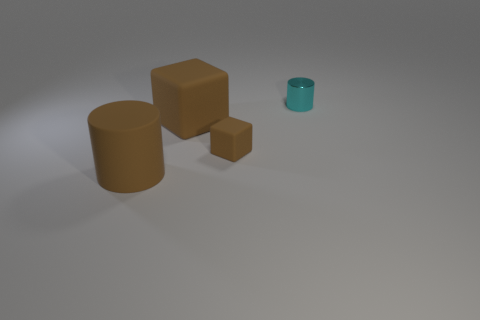Are there any other things that are the same size as the brown rubber cylinder?
Your answer should be very brief. Yes. Do the small matte object and the metallic object have the same color?
Offer a terse response. No. Is the number of small cyan objects greater than the number of large red matte cylinders?
Offer a very short reply. Yes. How many other things are the same color as the small rubber cube?
Ensure brevity in your answer.  2. There is a small thing that is in front of the small shiny cylinder; how many brown matte objects are behind it?
Provide a short and direct response. 1. There is a cyan thing; are there any large matte blocks on the left side of it?
Your response must be concise. Yes. There is a brown rubber object that is to the left of the matte thing behind the small matte object; what is its shape?
Keep it short and to the point. Cylinder. Are there fewer tiny brown things on the right side of the metallic cylinder than large brown matte objects that are behind the tiny rubber object?
Ensure brevity in your answer.  Yes. What is the color of the big rubber thing that is the same shape as the tiny brown rubber object?
Make the answer very short. Brown. How many things are both behind the brown cylinder and to the left of the cyan shiny thing?
Your answer should be very brief. 2. 